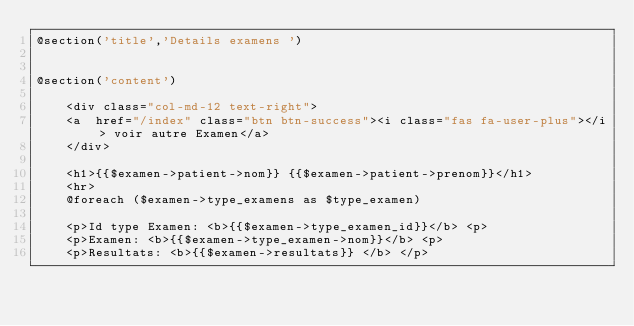<code> <loc_0><loc_0><loc_500><loc_500><_PHP_>@section('title','Details examens ')


@section('content')

    <div class="col-md-12 text-right">
    <a  href="/index" class="btn btn-success"><i class="fas fa-user-plus"></i> voir autre Examen</a>
    </div>

    <h1>{{$examen->patient->nom}} {{$examen->patient->prenom}}</h1>
    <hr>
    @foreach ($examen->type_examens as $type_examen)

    <p>Id type Examen: <b>{{$examen->type_examen_id}}</b> <p>
    <p>Examen: <b>{{$examen->type_examen->nom}}</b> <p>   
    <p>Resultats: <b>{{$examen->resultats}} </b> </p></code> 